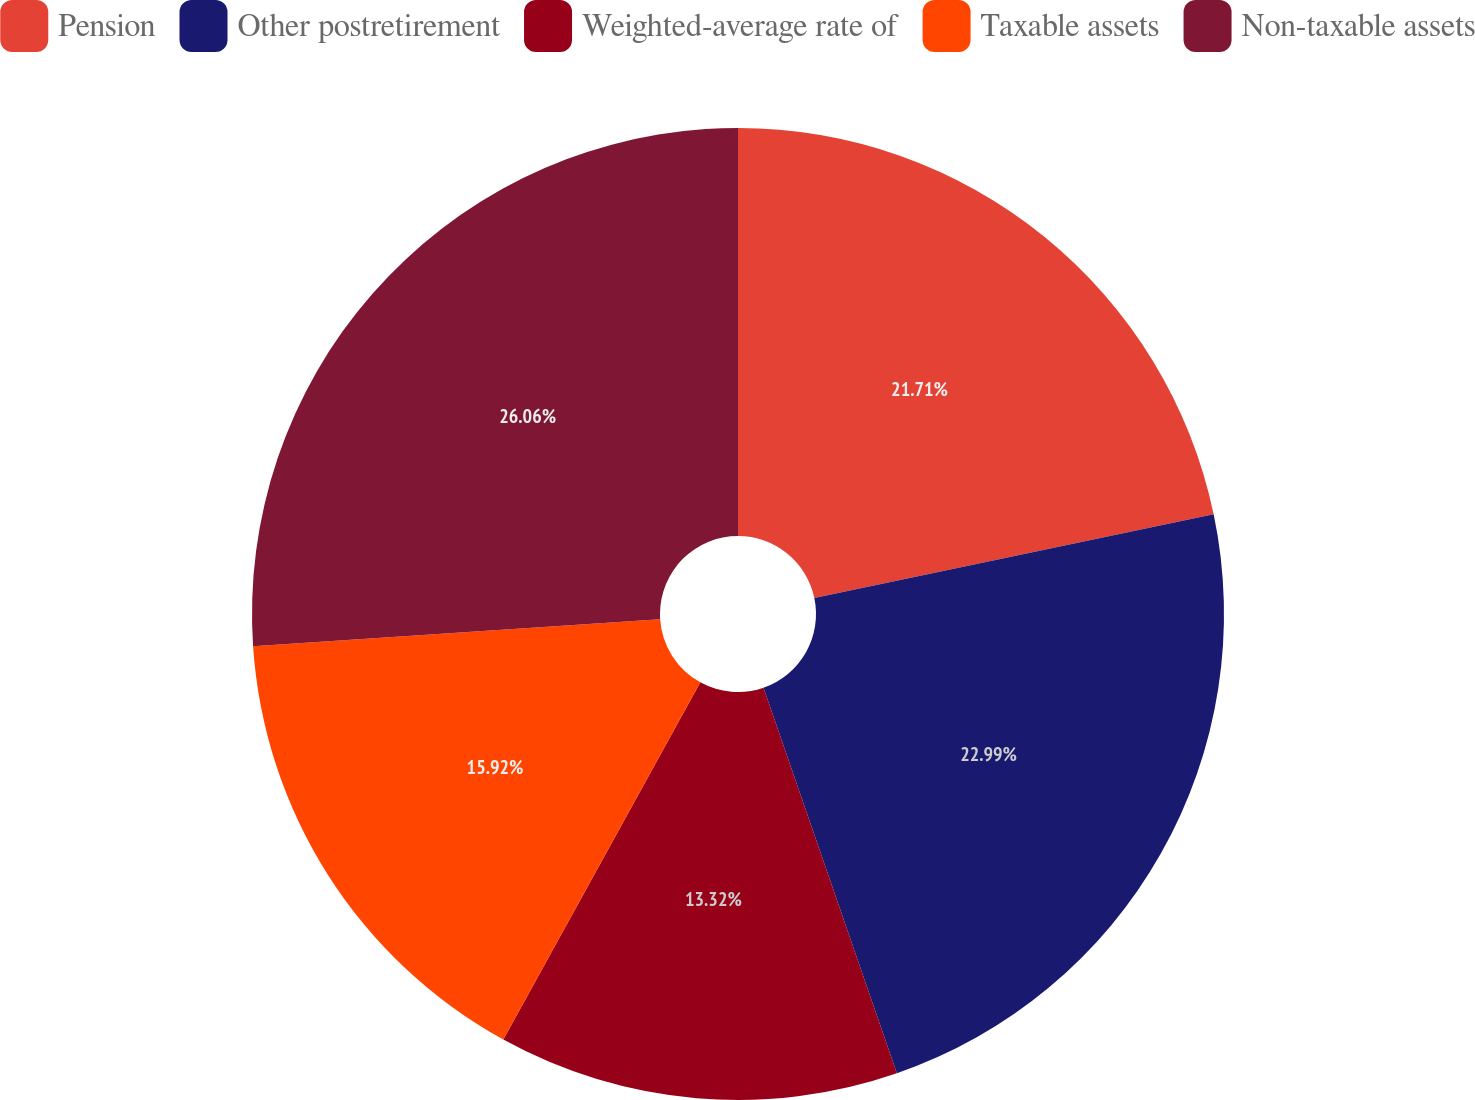Convert chart to OTSL. <chart><loc_0><loc_0><loc_500><loc_500><pie_chart><fcel>Pension<fcel>Other postretirement<fcel>Weighted-average rate of<fcel>Taxable assets<fcel>Non-taxable assets<nl><fcel>21.71%<fcel>22.99%<fcel>13.32%<fcel>15.92%<fcel>26.06%<nl></chart> 